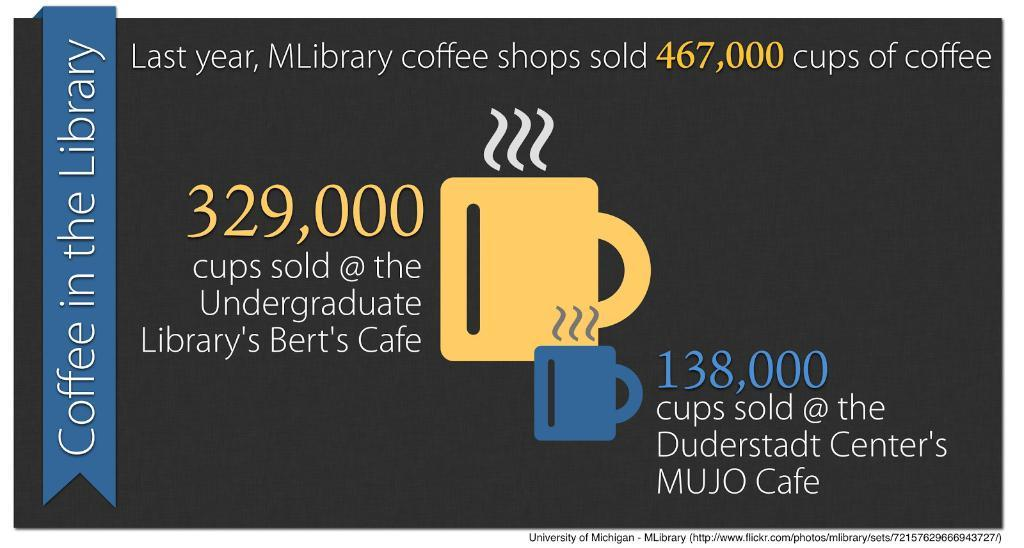Provide a one-sentence caption for the provided image. A certificate for a library, that says 329,000 in the center with yellow letters. 